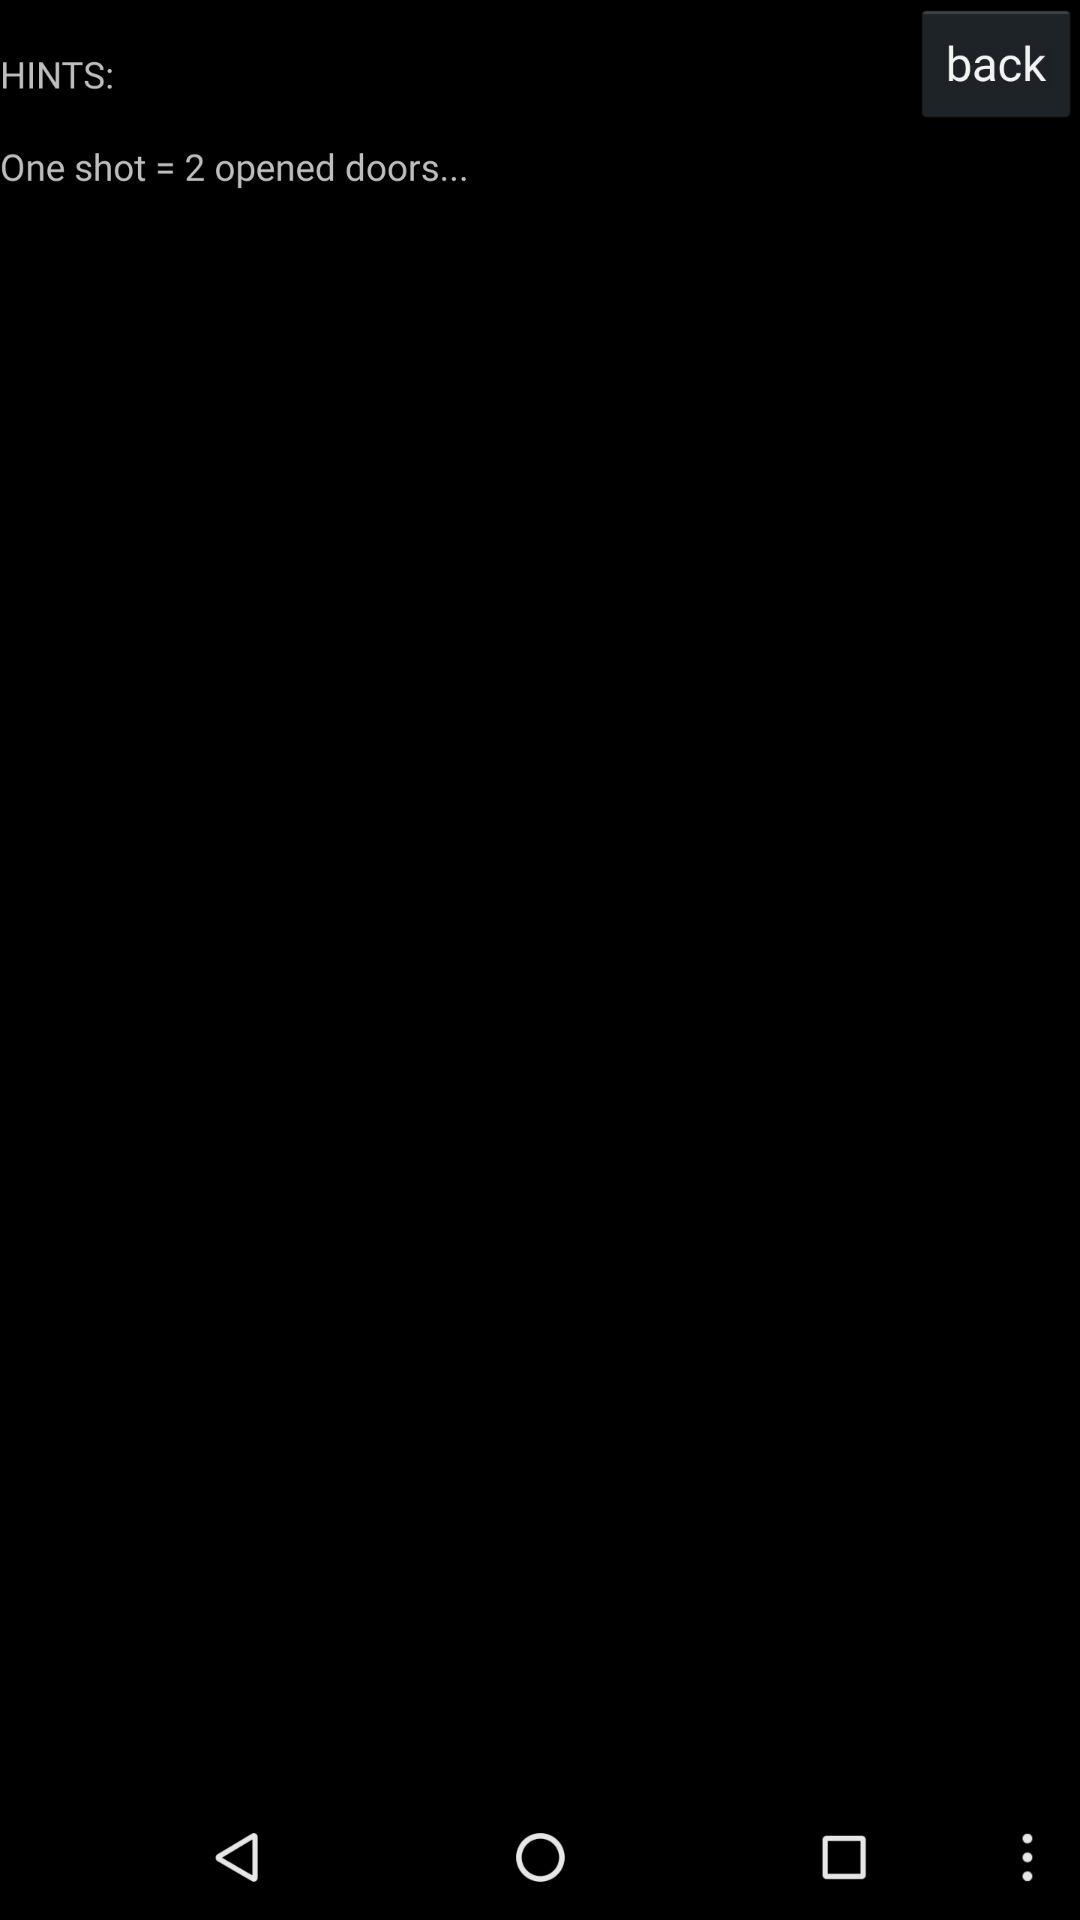How many doors are open? There are two open doors. 